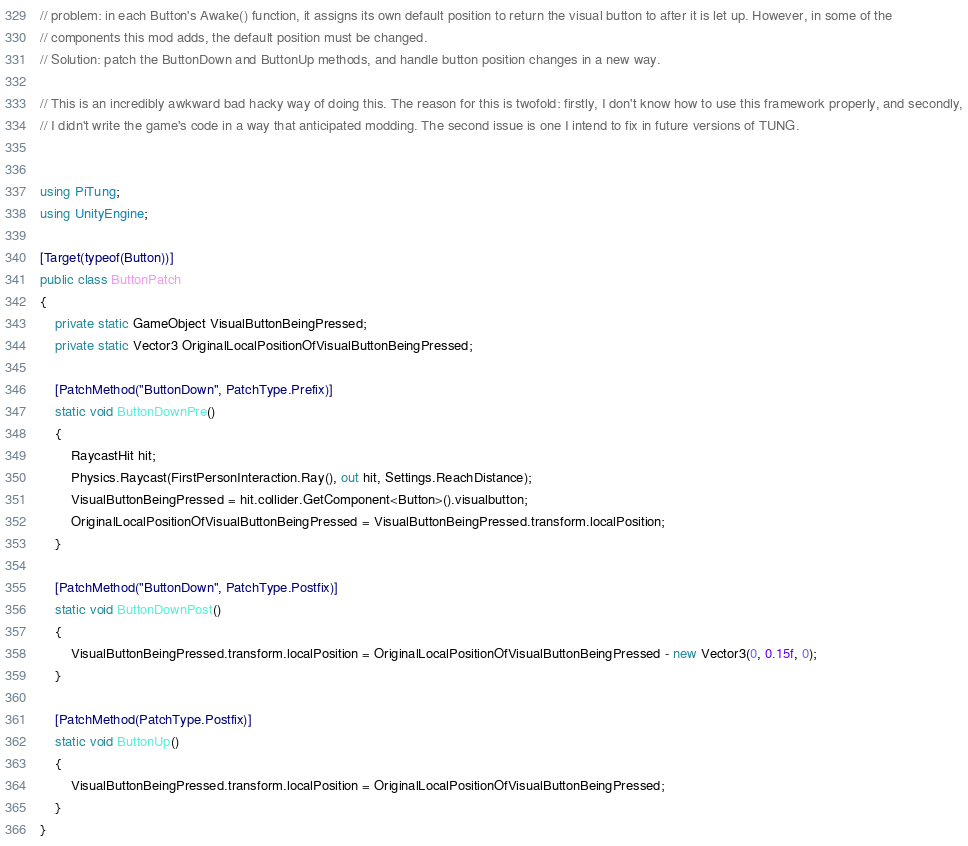Convert code to text. <code><loc_0><loc_0><loc_500><loc_500><_C#_>// problem: in each Button's Awake() function, it assigns its own default position to return the visual button to after it is let up. However, in some of the
// components this mod adds, the default position must be changed.
// Solution: patch the ButtonDown and ButtonUp methods, and handle button position changes in a new way.

// This is an incredibly awkward bad hacky way of doing this. The reason for this is twofold: firstly, I don't know how to use this framework properly, and secondly,
// I didn't write the game's code in a way that anticipated modding. The second issue is one I intend to fix in future versions of TUNG.


using PiTung;
using UnityEngine;

[Target(typeof(Button))]
public class ButtonPatch
{
    private static GameObject VisualButtonBeingPressed;
    private static Vector3 OriginalLocalPositionOfVisualButtonBeingPressed;

    [PatchMethod("ButtonDown", PatchType.Prefix)]
    static void ButtonDownPre()
    {
        RaycastHit hit;
        Physics.Raycast(FirstPersonInteraction.Ray(), out hit, Settings.ReachDistance);
        VisualButtonBeingPressed = hit.collider.GetComponent<Button>().visualbutton;
        OriginalLocalPositionOfVisualButtonBeingPressed = VisualButtonBeingPressed.transform.localPosition;
    }

    [PatchMethod("ButtonDown", PatchType.Postfix)]
    static void ButtonDownPost()
    {
        VisualButtonBeingPressed.transform.localPosition = OriginalLocalPositionOfVisualButtonBeingPressed - new Vector3(0, 0.15f, 0);
    }

    [PatchMethod(PatchType.Postfix)]
    static void ButtonUp()
    {
        VisualButtonBeingPressed.transform.localPosition = OriginalLocalPositionOfVisualButtonBeingPressed;
    }
}
</code> 